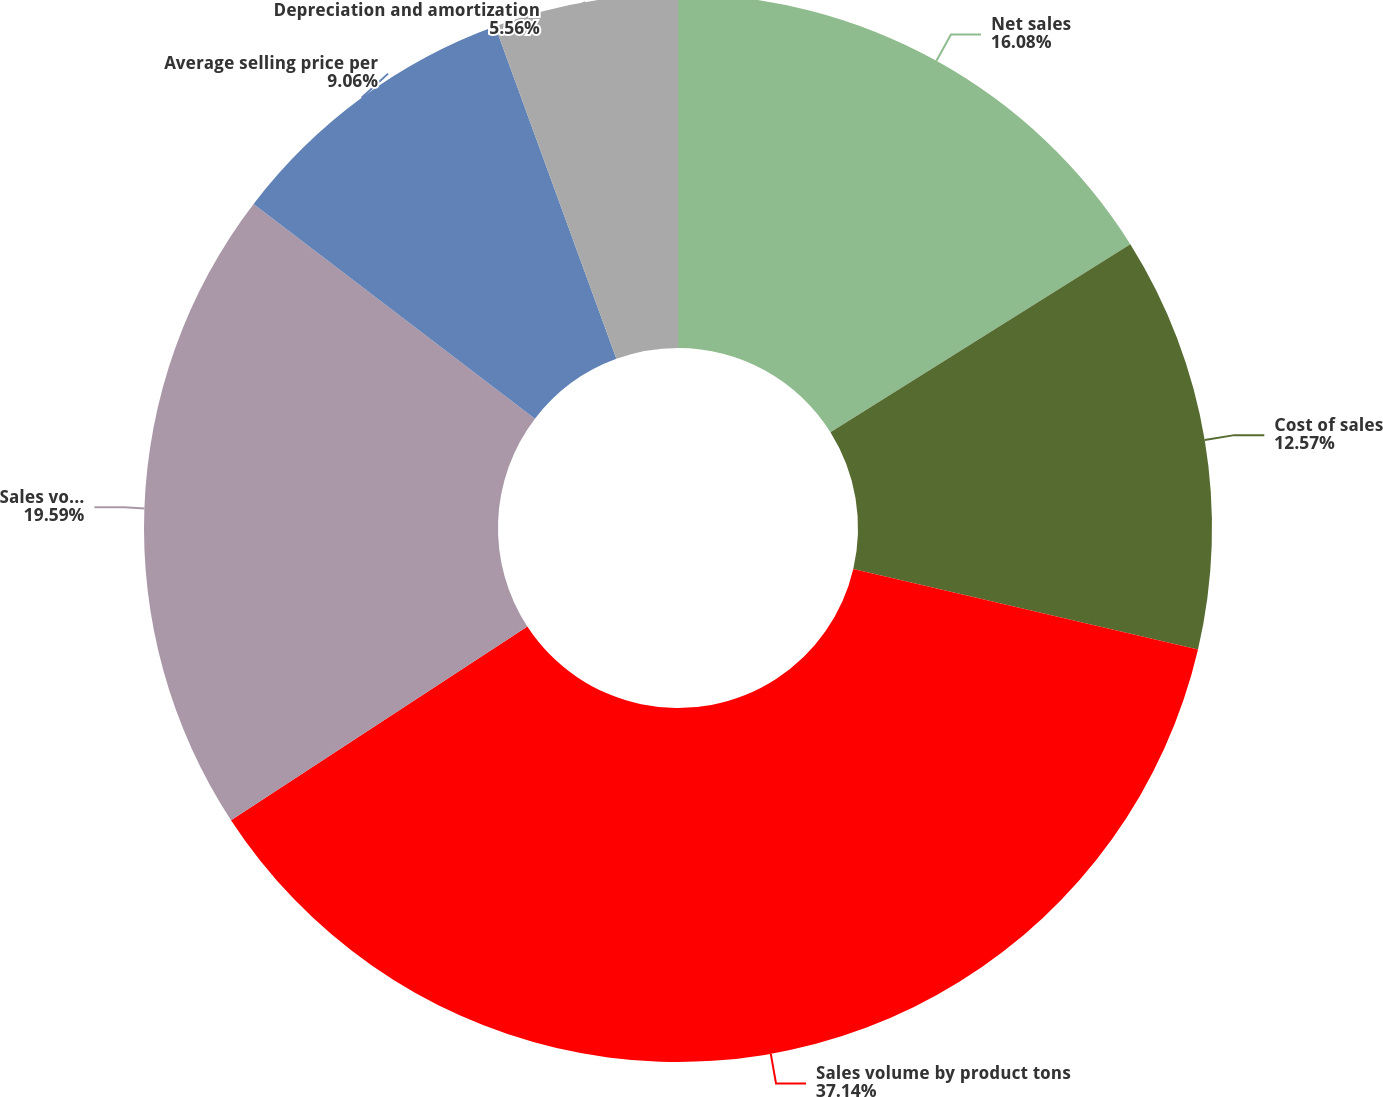<chart> <loc_0><loc_0><loc_500><loc_500><pie_chart><fcel>Net sales<fcel>Cost of sales<fcel>Sales volume by product tons<fcel>Sales volume by nutrient tons<fcel>Average selling price per<fcel>Depreciation and amortization<nl><fcel>16.08%<fcel>12.57%<fcel>37.13%<fcel>19.59%<fcel>9.06%<fcel>5.56%<nl></chart> 